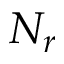Convert formula to latex. <formula><loc_0><loc_0><loc_500><loc_500>N _ { r }</formula> 